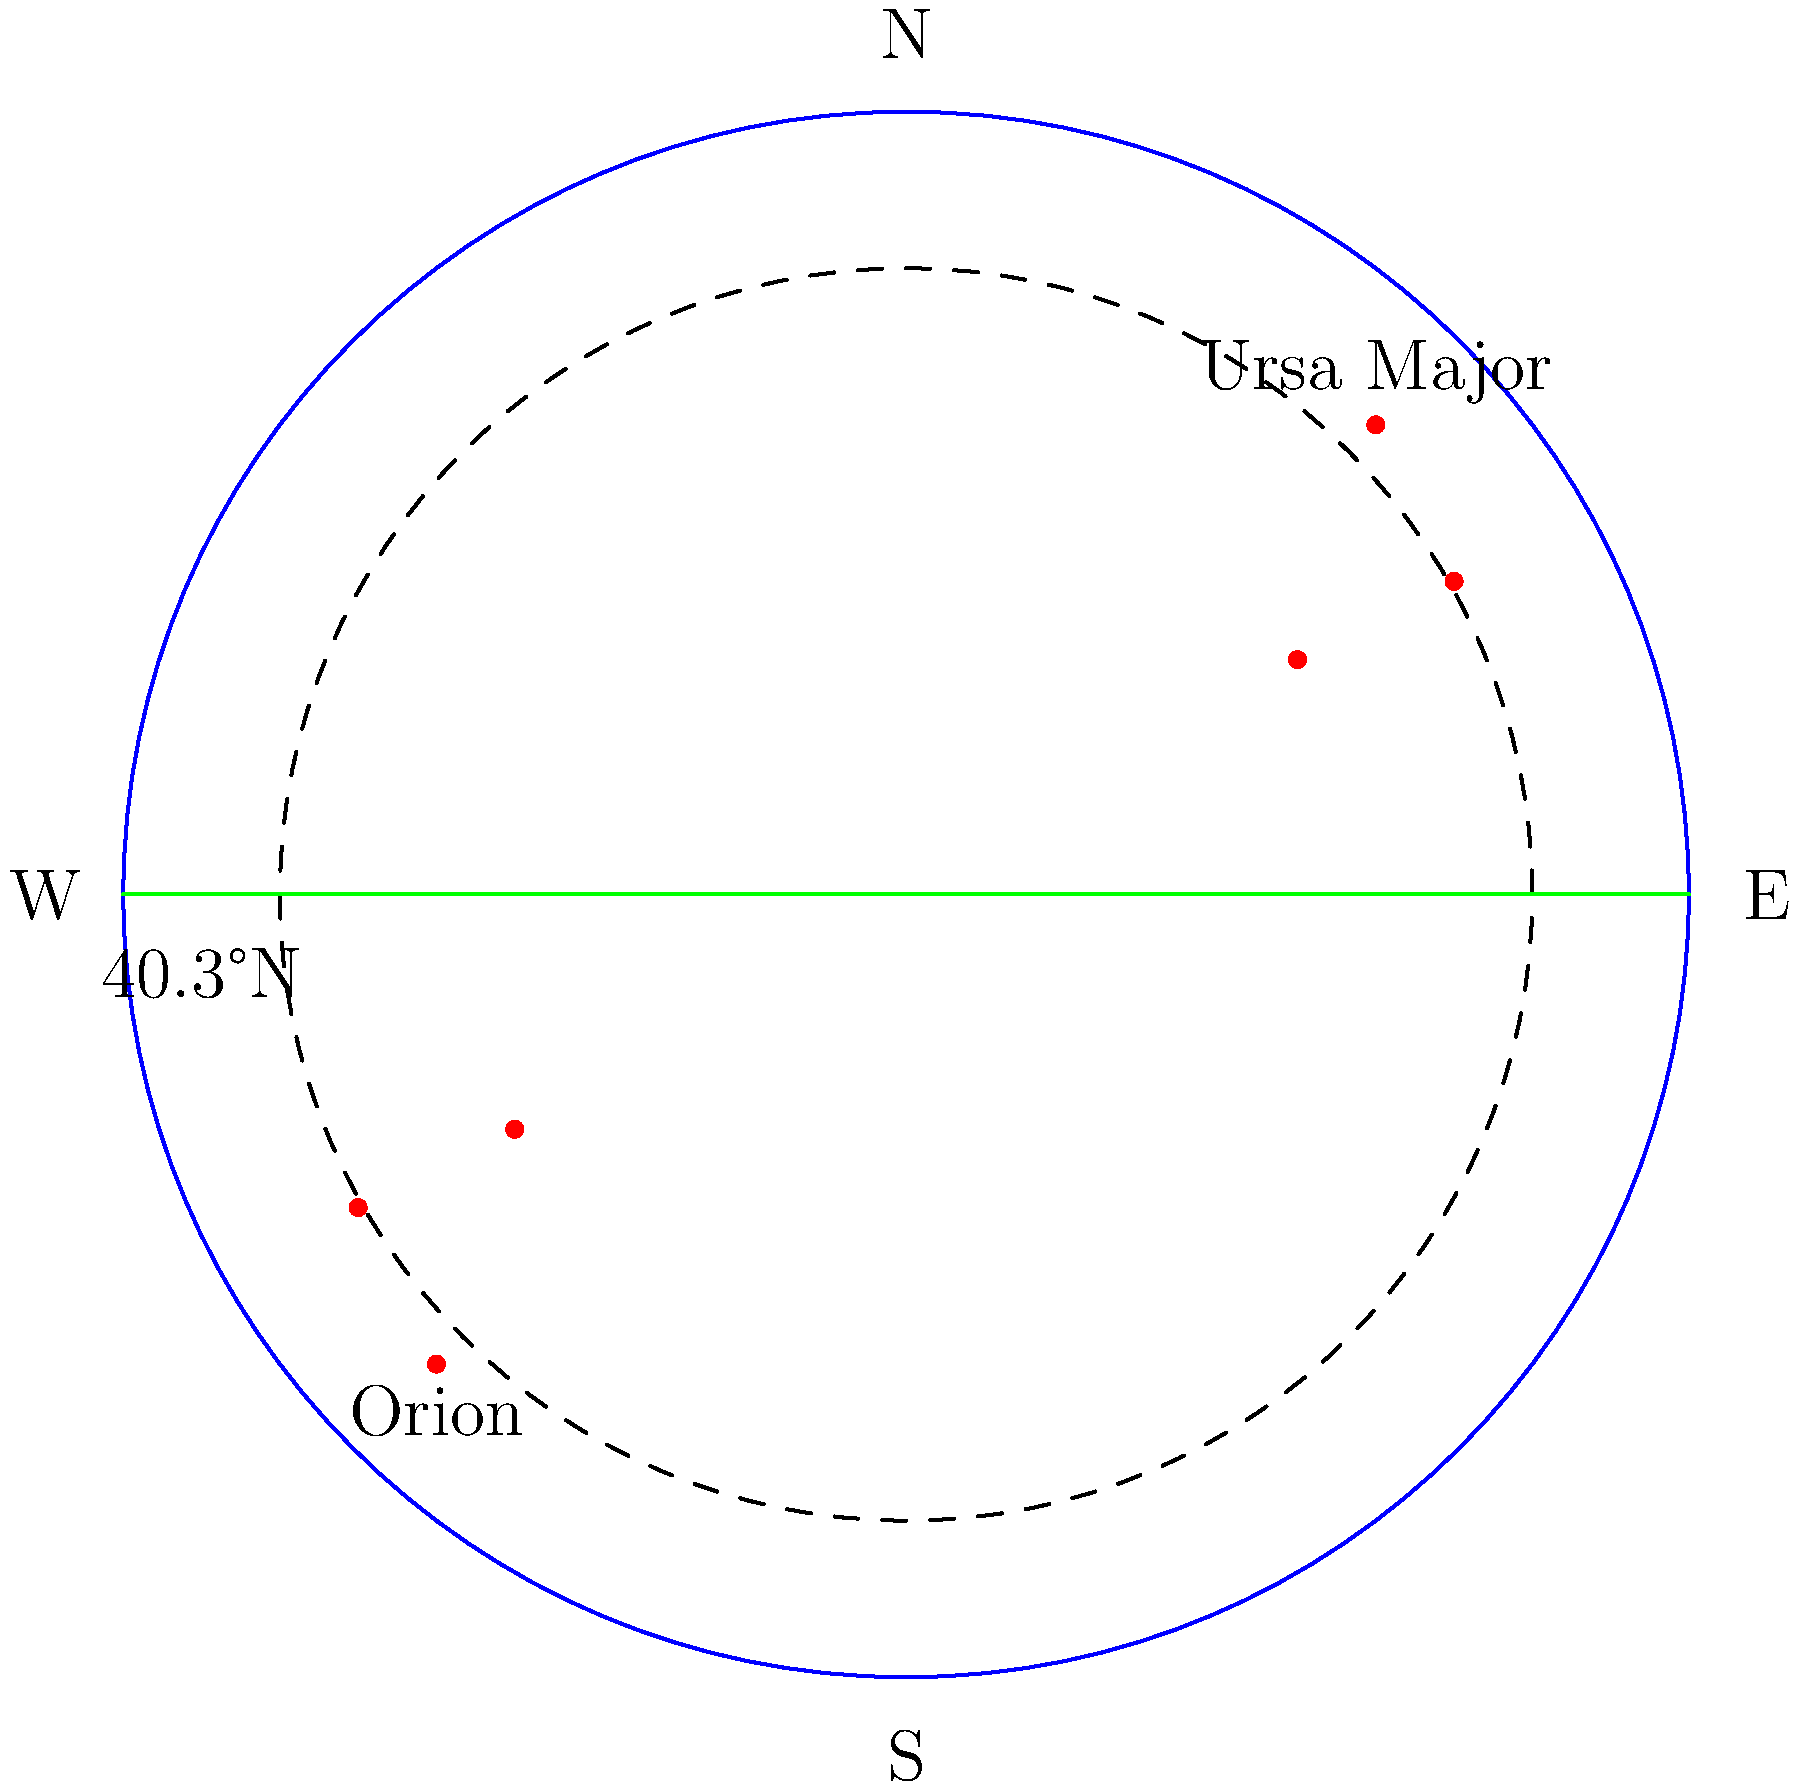As a sustainability-conscious Princeton alumnus, you're aware of the importance of understanding natural cycles. Which of the constellations shown in the diagram would be visible from Princeton (40.3°N latitude) during a summer evening, and why? To determine which constellation is visible from Princeton during a summer evening, we need to consider the following steps:

1. Latitude of Princeton: 40.3°N
2. Season: Summer
3. Time: Evening

Step 1: Understand the celestial sphere representation
- The diagram shows a simplified celestial sphere with the observer at the center.
- The green line represents the horizon.
- The dashed circle represents the celestial equator.

Step 2: Analyze the positions of the constellations
- Ursa Major is shown in the northern part of the sky (above the celestial equator).
- Orion is shown in the southern part of the sky (below the celestial equator).

Step 3: Consider the effects of latitude and season
- At 40.3°N, more of the northern sky is visible compared to the southern sky.
- In summer, the North Celestial Pole is tilted towards the Sun, making northern constellations more prominent.

Step 4: Evaluate visibility during summer evenings
- Ursa Major, being a northern constellation, is circumpolar at Princeton's latitude, meaning it's visible year-round.
- Orion is a winter constellation in the Northern Hemisphere. In summer evenings, it's below the horizon and not visible.

Therefore, based on its position in the northern sky and its circumpolar nature at Princeton's latitude, Ursa Major would be visible during a summer evening.
Answer: Ursa Major 